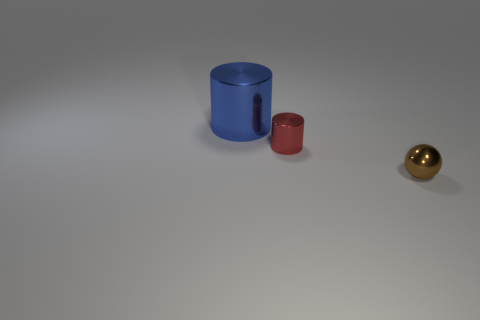What number of large blue metallic things are the same shape as the red thing?
Offer a terse response. 1. Are there fewer tiny gray things than small spheres?
Give a very brief answer. Yes. There is a red object that is the same size as the sphere; what material is it?
Ensure brevity in your answer.  Metal. Do the cylinder to the right of the blue cylinder and the blue shiny cylinder have the same size?
Keep it short and to the point. No. Is the number of small brown objects greater than the number of tiny objects?
Your answer should be compact. No. How many large objects are either red objects or yellow matte cylinders?
Make the answer very short. 0. What number of tiny brown things are the same material as the large cylinder?
Provide a succinct answer. 1. How many brown objects are small things or metallic cylinders?
Keep it short and to the point. 1. What number of objects are brown spheres or shiny objects on the right side of the big cylinder?
Your answer should be compact. 2. How many metallic things are left of the small metallic object behind the thing that is in front of the small red metallic cylinder?
Provide a succinct answer. 1. 